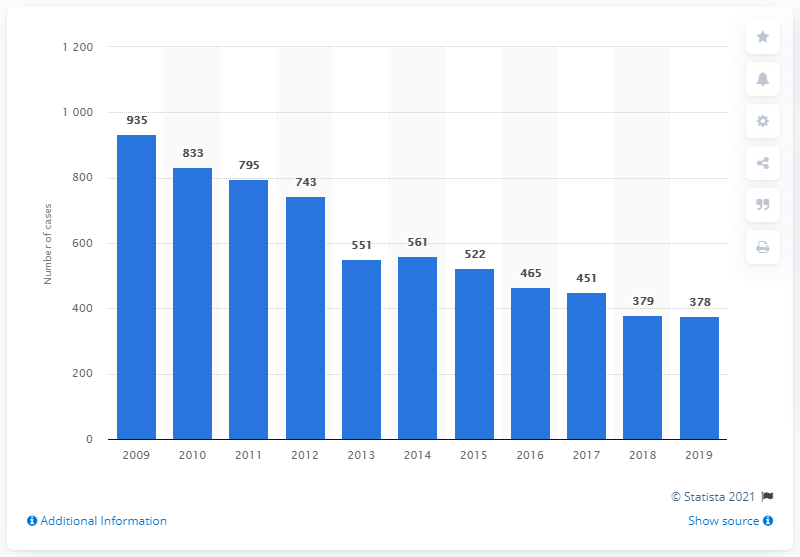Identify some key points in this picture. In 2019, there were 378 homicide cases reported in Taiwan. 